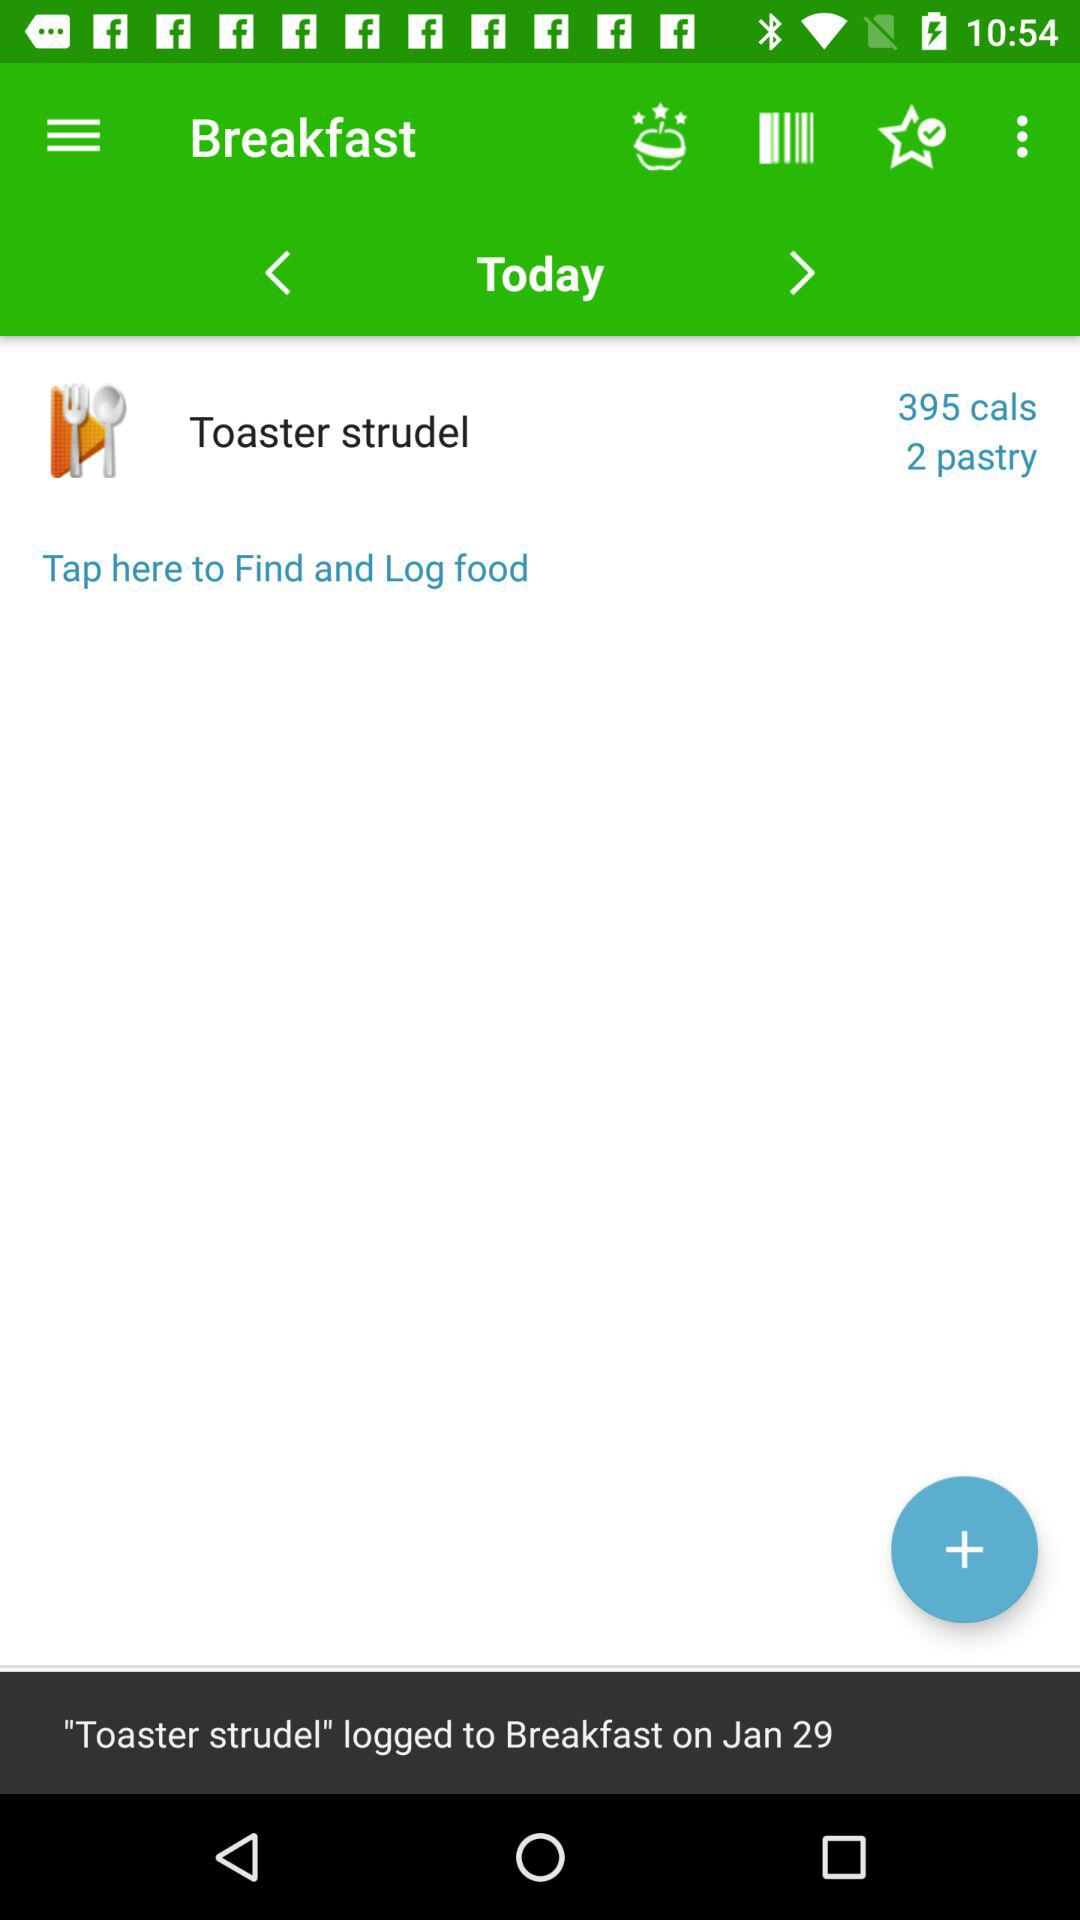What day is selected? The selected day is today. 